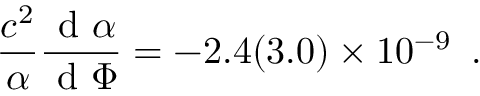<formula> <loc_0><loc_0><loc_500><loc_500>\frac { c ^ { 2 } } { \alpha } \frac { d \alpha } { d \Phi } = - 2 . 4 ( 3 . 0 ) \times 1 0 ^ { - 9 } \, .</formula> 